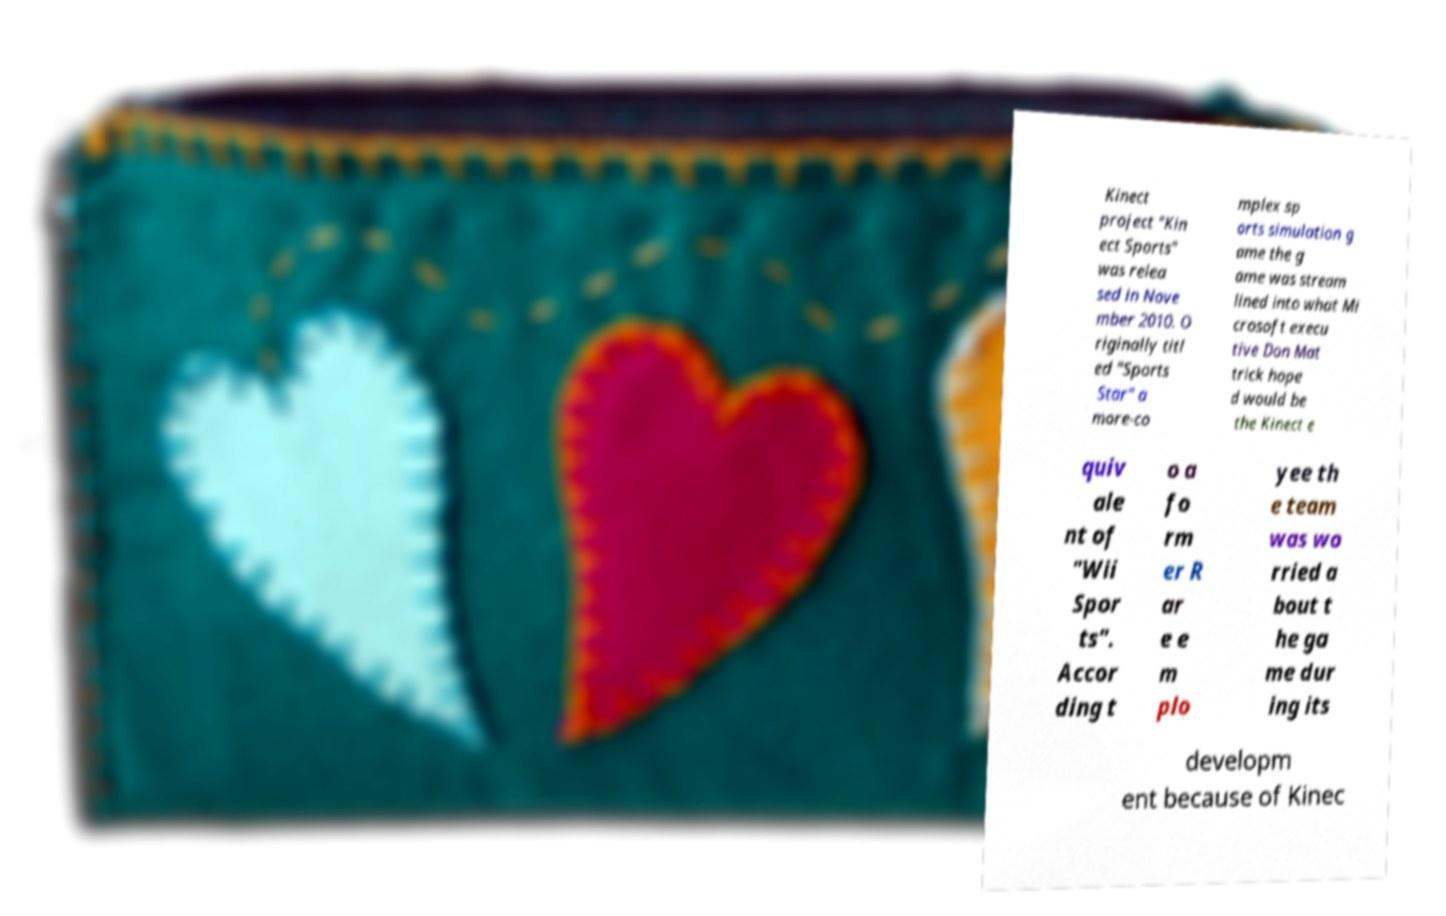What messages or text are displayed in this image? I need them in a readable, typed format. Kinect project "Kin ect Sports" was relea sed in Nove mber 2010. O riginally titl ed "Sports Star" a more-co mplex sp orts simulation g ame the g ame was stream lined into what Mi crosoft execu tive Don Mat trick hope d would be the Kinect e quiv ale nt of "Wii Spor ts". Accor ding t o a fo rm er R ar e e m plo yee th e team was wo rried a bout t he ga me dur ing its developm ent because of Kinec 